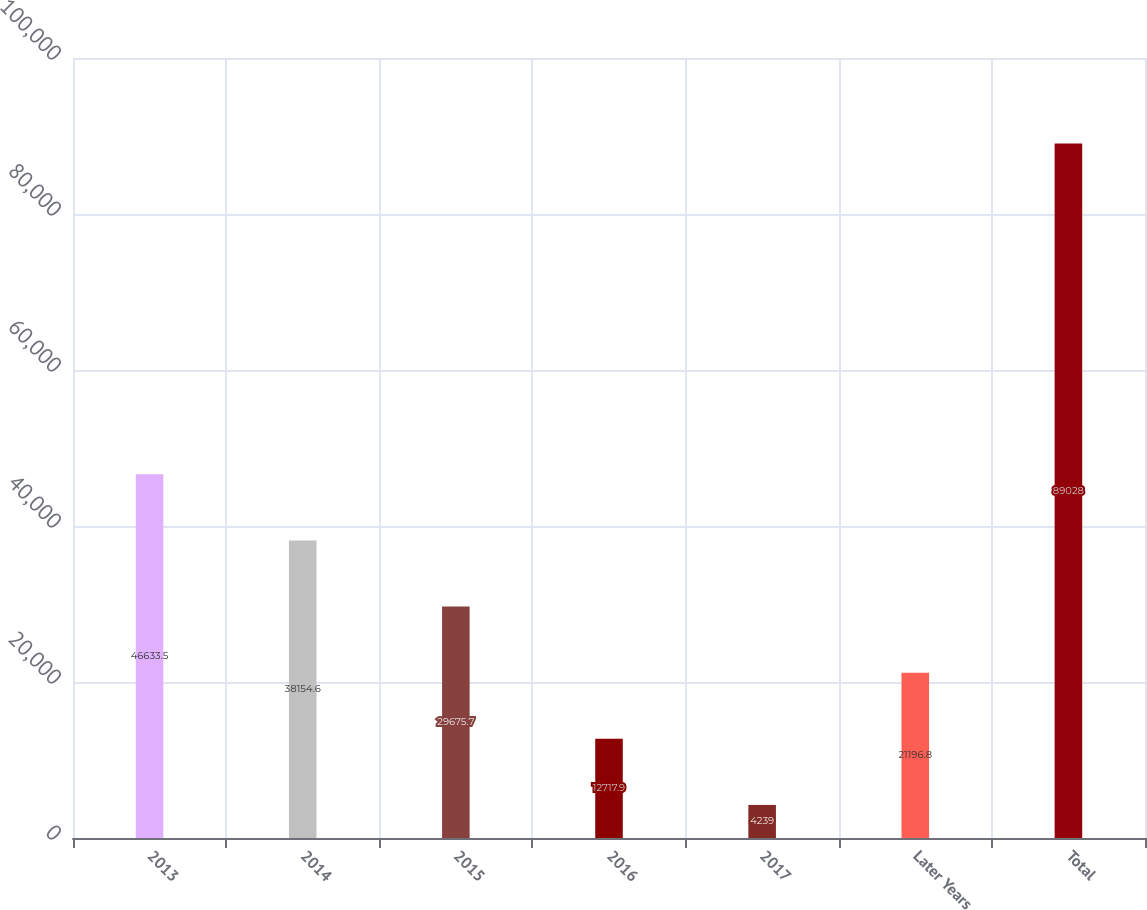Convert chart. <chart><loc_0><loc_0><loc_500><loc_500><bar_chart><fcel>2013<fcel>2014<fcel>2015<fcel>2016<fcel>2017<fcel>Later Years<fcel>Total<nl><fcel>46633.5<fcel>38154.6<fcel>29675.7<fcel>12717.9<fcel>4239<fcel>21196.8<fcel>89028<nl></chart> 